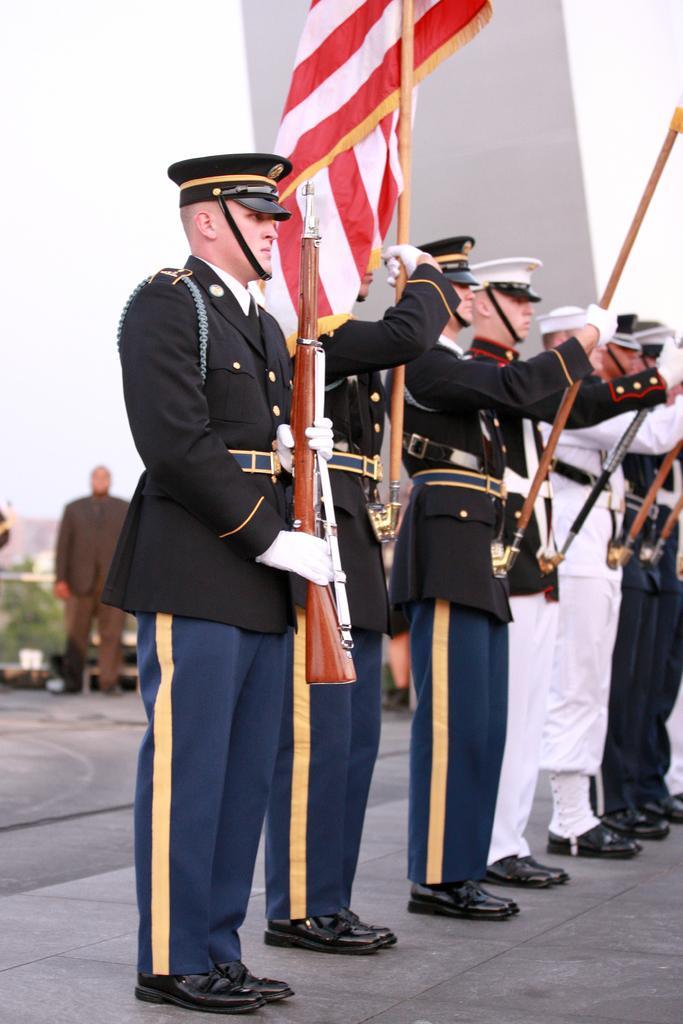How would you summarize this image in a sentence or two? In the image in the center, we can see few people are standing and they are holding some objects like, one gun, one flagsticks, etc.. And we can see they are wearing caps and they are in different costumes. In the background we can see the sky, plant, one person standing etc. 